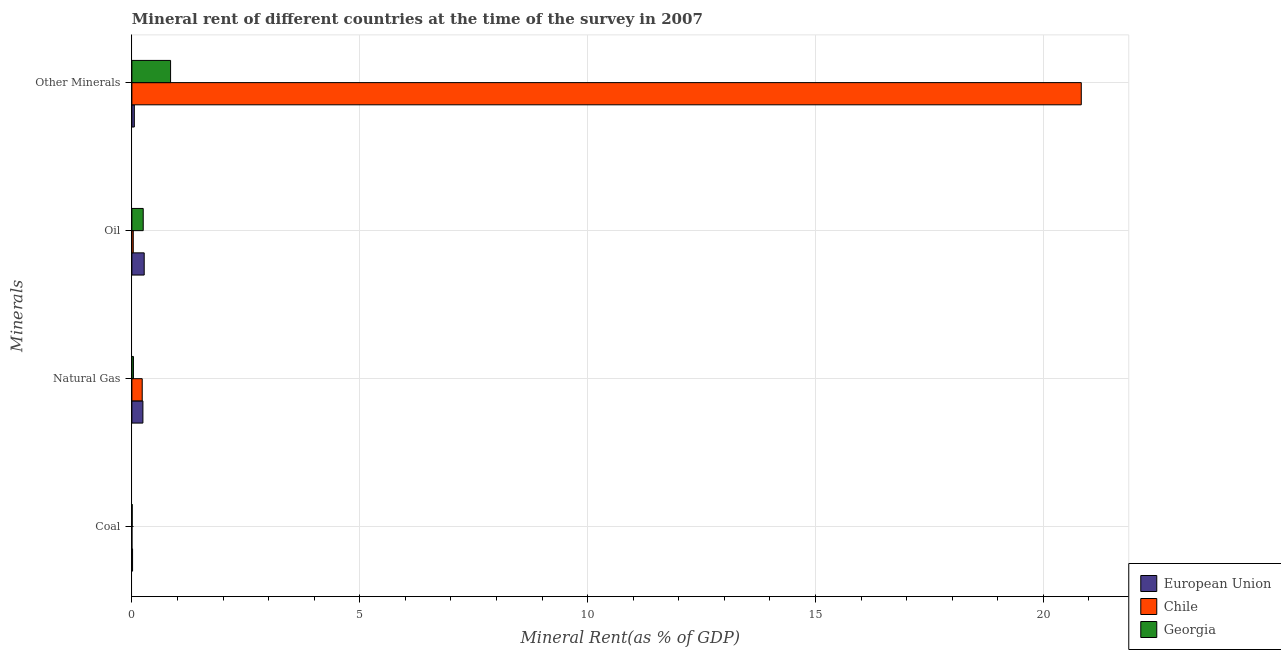How many different coloured bars are there?
Offer a very short reply. 3. Are the number of bars on each tick of the Y-axis equal?
Offer a terse response. Yes. How many bars are there on the 1st tick from the top?
Provide a succinct answer. 3. How many bars are there on the 1st tick from the bottom?
Give a very brief answer. 3. What is the label of the 1st group of bars from the top?
Your answer should be compact. Other Minerals. What is the oil rent in Chile?
Give a very brief answer. 0.03. Across all countries, what is the maximum natural gas rent?
Keep it short and to the point. 0.24. Across all countries, what is the minimum natural gas rent?
Ensure brevity in your answer.  0.03. What is the total oil rent in the graph?
Your answer should be very brief. 0.55. What is the difference between the  rent of other minerals in European Union and that in Chile?
Give a very brief answer. -20.78. What is the difference between the natural gas rent in Chile and the oil rent in European Union?
Your answer should be very brief. -0.04. What is the average  rent of other minerals per country?
Make the answer very short. 7.25. What is the difference between the coal rent and  rent of other minerals in Georgia?
Offer a very short reply. -0.84. In how many countries, is the oil rent greater than 20 %?
Give a very brief answer. 0. What is the ratio of the  rent of other minerals in Chile to that in Georgia?
Your response must be concise. 24.53. Is the  rent of other minerals in Georgia less than that in European Union?
Ensure brevity in your answer.  No. What is the difference between the highest and the second highest coal rent?
Provide a short and direct response. 0.01. What is the difference between the highest and the lowest oil rent?
Your response must be concise. 0.24. Is it the case that in every country, the sum of the natural gas rent and coal rent is greater than the sum of  rent of other minerals and oil rent?
Your answer should be compact. No. What does the 2nd bar from the top in Coal represents?
Offer a very short reply. Chile. What does the 3rd bar from the bottom in Oil represents?
Offer a terse response. Georgia. Is it the case that in every country, the sum of the coal rent and natural gas rent is greater than the oil rent?
Your answer should be compact. No. How many bars are there?
Make the answer very short. 12. Are all the bars in the graph horizontal?
Provide a succinct answer. Yes. How many countries are there in the graph?
Provide a succinct answer. 3. Are the values on the major ticks of X-axis written in scientific E-notation?
Offer a very short reply. No. Does the graph contain any zero values?
Your answer should be compact. No. Does the graph contain grids?
Your answer should be compact. Yes. How are the legend labels stacked?
Your response must be concise. Vertical. What is the title of the graph?
Keep it short and to the point. Mineral rent of different countries at the time of the survey in 2007. What is the label or title of the X-axis?
Provide a succinct answer. Mineral Rent(as % of GDP). What is the label or title of the Y-axis?
Give a very brief answer. Minerals. What is the Mineral Rent(as % of GDP) in European Union in Coal?
Ensure brevity in your answer.  0.01. What is the Mineral Rent(as % of GDP) in Chile in Coal?
Your answer should be compact. 0. What is the Mineral Rent(as % of GDP) in Georgia in Coal?
Give a very brief answer. 0.01. What is the Mineral Rent(as % of GDP) of European Union in Natural Gas?
Your response must be concise. 0.24. What is the Mineral Rent(as % of GDP) of Chile in Natural Gas?
Your response must be concise. 0.23. What is the Mineral Rent(as % of GDP) of Georgia in Natural Gas?
Provide a short and direct response. 0.03. What is the Mineral Rent(as % of GDP) in European Union in Oil?
Ensure brevity in your answer.  0.27. What is the Mineral Rent(as % of GDP) in Chile in Oil?
Ensure brevity in your answer.  0.03. What is the Mineral Rent(as % of GDP) of Georgia in Oil?
Your answer should be compact. 0.25. What is the Mineral Rent(as % of GDP) in European Union in Other Minerals?
Your response must be concise. 0.05. What is the Mineral Rent(as % of GDP) of Chile in Other Minerals?
Offer a terse response. 20.83. What is the Mineral Rent(as % of GDP) of Georgia in Other Minerals?
Offer a very short reply. 0.85. Across all Minerals, what is the maximum Mineral Rent(as % of GDP) in European Union?
Provide a short and direct response. 0.27. Across all Minerals, what is the maximum Mineral Rent(as % of GDP) in Chile?
Give a very brief answer. 20.83. Across all Minerals, what is the maximum Mineral Rent(as % of GDP) of Georgia?
Your response must be concise. 0.85. Across all Minerals, what is the minimum Mineral Rent(as % of GDP) of European Union?
Give a very brief answer. 0.01. Across all Minerals, what is the minimum Mineral Rent(as % of GDP) of Chile?
Your answer should be very brief. 0. Across all Minerals, what is the minimum Mineral Rent(as % of GDP) in Georgia?
Your answer should be very brief. 0.01. What is the total Mineral Rent(as % of GDP) in European Union in the graph?
Offer a very short reply. 0.58. What is the total Mineral Rent(as % of GDP) in Chile in the graph?
Make the answer very short. 21.09. What is the total Mineral Rent(as % of GDP) of Georgia in the graph?
Give a very brief answer. 1.14. What is the difference between the Mineral Rent(as % of GDP) in European Union in Coal and that in Natural Gas?
Your answer should be compact. -0.23. What is the difference between the Mineral Rent(as % of GDP) of Chile in Coal and that in Natural Gas?
Ensure brevity in your answer.  -0.23. What is the difference between the Mineral Rent(as % of GDP) in Georgia in Coal and that in Natural Gas?
Provide a short and direct response. -0.03. What is the difference between the Mineral Rent(as % of GDP) in European Union in Coal and that in Oil?
Offer a very short reply. -0.26. What is the difference between the Mineral Rent(as % of GDP) of Chile in Coal and that in Oil?
Your answer should be very brief. -0.03. What is the difference between the Mineral Rent(as % of GDP) of Georgia in Coal and that in Oil?
Ensure brevity in your answer.  -0.24. What is the difference between the Mineral Rent(as % of GDP) in European Union in Coal and that in Other Minerals?
Keep it short and to the point. -0.04. What is the difference between the Mineral Rent(as % of GDP) of Chile in Coal and that in Other Minerals?
Make the answer very short. -20.83. What is the difference between the Mineral Rent(as % of GDP) in Georgia in Coal and that in Other Minerals?
Keep it short and to the point. -0.84. What is the difference between the Mineral Rent(as % of GDP) in European Union in Natural Gas and that in Oil?
Provide a short and direct response. -0.03. What is the difference between the Mineral Rent(as % of GDP) in Chile in Natural Gas and that in Oil?
Keep it short and to the point. 0.2. What is the difference between the Mineral Rent(as % of GDP) of Georgia in Natural Gas and that in Oil?
Give a very brief answer. -0.21. What is the difference between the Mineral Rent(as % of GDP) in European Union in Natural Gas and that in Other Minerals?
Offer a terse response. 0.19. What is the difference between the Mineral Rent(as % of GDP) of Chile in Natural Gas and that in Other Minerals?
Provide a succinct answer. -20.61. What is the difference between the Mineral Rent(as % of GDP) of Georgia in Natural Gas and that in Other Minerals?
Offer a terse response. -0.81. What is the difference between the Mineral Rent(as % of GDP) of European Union in Oil and that in Other Minerals?
Offer a very short reply. 0.22. What is the difference between the Mineral Rent(as % of GDP) of Chile in Oil and that in Other Minerals?
Keep it short and to the point. -20.8. What is the difference between the Mineral Rent(as % of GDP) of Georgia in Oil and that in Other Minerals?
Make the answer very short. -0.6. What is the difference between the Mineral Rent(as % of GDP) in European Union in Coal and the Mineral Rent(as % of GDP) in Chile in Natural Gas?
Keep it short and to the point. -0.21. What is the difference between the Mineral Rent(as % of GDP) in European Union in Coal and the Mineral Rent(as % of GDP) in Georgia in Natural Gas?
Make the answer very short. -0.02. What is the difference between the Mineral Rent(as % of GDP) in Chile in Coal and the Mineral Rent(as % of GDP) in Georgia in Natural Gas?
Make the answer very short. -0.03. What is the difference between the Mineral Rent(as % of GDP) of European Union in Coal and the Mineral Rent(as % of GDP) of Chile in Oil?
Give a very brief answer. -0.02. What is the difference between the Mineral Rent(as % of GDP) in European Union in Coal and the Mineral Rent(as % of GDP) in Georgia in Oil?
Your answer should be very brief. -0.23. What is the difference between the Mineral Rent(as % of GDP) of Chile in Coal and the Mineral Rent(as % of GDP) of Georgia in Oil?
Provide a short and direct response. -0.25. What is the difference between the Mineral Rent(as % of GDP) in European Union in Coal and the Mineral Rent(as % of GDP) in Chile in Other Minerals?
Provide a short and direct response. -20.82. What is the difference between the Mineral Rent(as % of GDP) of European Union in Coal and the Mineral Rent(as % of GDP) of Georgia in Other Minerals?
Make the answer very short. -0.83. What is the difference between the Mineral Rent(as % of GDP) of Chile in Coal and the Mineral Rent(as % of GDP) of Georgia in Other Minerals?
Make the answer very short. -0.85. What is the difference between the Mineral Rent(as % of GDP) of European Union in Natural Gas and the Mineral Rent(as % of GDP) of Chile in Oil?
Keep it short and to the point. 0.21. What is the difference between the Mineral Rent(as % of GDP) in European Union in Natural Gas and the Mineral Rent(as % of GDP) in Georgia in Oil?
Make the answer very short. -0.01. What is the difference between the Mineral Rent(as % of GDP) in Chile in Natural Gas and the Mineral Rent(as % of GDP) in Georgia in Oil?
Offer a very short reply. -0.02. What is the difference between the Mineral Rent(as % of GDP) in European Union in Natural Gas and the Mineral Rent(as % of GDP) in Chile in Other Minerals?
Give a very brief answer. -20.59. What is the difference between the Mineral Rent(as % of GDP) of European Union in Natural Gas and the Mineral Rent(as % of GDP) of Georgia in Other Minerals?
Ensure brevity in your answer.  -0.61. What is the difference between the Mineral Rent(as % of GDP) in Chile in Natural Gas and the Mineral Rent(as % of GDP) in Georgia in Other Minerals?
Provide a short and direct response. -0.62. What is the difference between the Mineral Rent(as % of GDP) of European Union in Oil and the Mineral Rent(as % of GDP) of Chile in Other Minerals?
Your answer should be very brief. -20.56. What is the difference between the Mineral Rent(as % of GDP) in European Union in Oil and the Mineral Rent(as % of GDP) in Georgia in Other Minerals?
Your answer should be very brief. -0.58. What is the difference between the Mineral Rent(as % of GDP) of Chile in Oil and the Mineral Rent(as % of GDP) of Georgia in Other Minerals?
Ensure brevity in your answer.  -0.82. What is the average Mineral Rent(as % of GDP) in European Union per Minerals?
Your answer should be very brief. 0.15. What is the average Mineral Rent(as % of GDP) in Chile per Minerals?
Provide a short and direct response. 5.27. What is the average Mineral Rent(as % of GDP) in Georgia per Minerals?
Offer a terse response. 0.28. What is the difference between the Mineral Rent(as % of GDP) in European Union and Mineral Rent(as % of GDP) in Chile in Coal?
Provide a succinct answer. 0.01. What is the difference between the Mineral Rent(as % of GDP) of European Union and Mineral Rent(as % of GDP) of Georgia in Coal?
Make the answer very short. 0.01. What is the difference between the Mineral Rent(as % of GDP) of Chile and Mineral Rent(as % of GDP) of Georgia in Coal?
Ensure brevity in your answer.  -0.01. What is the difference between the Mineral Rent(as % of GDP) in European Union and Mineral Rent(as % of GDP) in Chile in Natural Gas?
Give a very brief answer. 0.02. What is the difference between the Mineral Rent(as % of GDP) in European Union and Mineral Rent(as % of GDP) in Georgia in Natural Gas?
Provide a succinct answer. 0.21. What is the difference between the Mineral Rent(as % of GDP) of Chile and Mineral Rent(as % of GDP) of Georgia in Natural Gas?
Your answer should be very brief. 0.19. What is the difference between the Mineral Rent(as % of GDP) of European Union and Mineral Rent(as % of GDP) of Chile in Oil?
Make the answer very short. 0.24. What is the difference between the Mineral Rent(as % of GDP) in European Union and Mineral Rent(as % of GDP) in Georgia in Oil?
Provide a succinct answer. 0.02. What is the difference between the Mineral Rent(as % of GDP) of Chile and Mineral Rent(as % of GDP) of Georgia in Oil?
Offer a very short reply. -0.22. What is the difference between the Mineral Rent(as % of GDP) of European Union and Mineral Rent(as % of GDP) of Chile in Other Minerals?
Your response must be concise. -20.78. What is the difference between the Mineral Rent(as % of GDP) of European Union and Mineral Rent(as % of GDP) of Georgia in Other Minerals?
Your answer should be compact. -0.8. What is the difference between the Mineral Rent(as % of GDP) of Chile and Mineral Rent(as % of GDP) of Georgia in Other Minerals?
Your answer should be compact. 19.98. What is the ratio of the Mineral Rent(as % of GDP) in European Union in Coal to that in Natural Gas?
Make the answer very short. 0.06. What is the ratio of the Mineral Rent(as % of GDP) in Chile in Coal to that in Natural Gas?
Your response must be concise. 0.01. What is the ratio of the Mineral Rent(as % of GDP) in Georgia in Coal to that in Natural Gas?
Your answer should be compact. 0.21. What is the ratio of the Mineral Rent(as % of GDP) in European Union in Coal to that in Oil?
Ensure brevity in your answer.  0.06. What is the ratio of the Mineral Rent(as % of GDP) of Chile in Coal to that in Oil?
Make the answer very short. 0.05. What is the ratio of the Mineral Rent(as % of GDP) of Georgia in Coal to that in Oil?
Offer a terse response. 0.03. What is the ratio of the Mineral Rent(as % of GDP) in European Union in Coal to that in Other Minerals?
Ensure brevity in your answer.  0.28. What is the ratio of the Mineral Rent(as % of GDP) of Chile in Coal to that in Other Minerals?
Provide a short and direct response. 0. What is the ratio of the Mineral Rent(as % of GDP) of Georgia in Coal to that in Other Minerals?
Offer a very short reply. 0.01. What is the ratio of the Mineral Rent(as % of GDP) of European Union in Natural Gas to that in Oil?
Your answer should be very brief. 0.9. What is the ratio of the Mineral Rent(as % of GDP) in Chile in Natural Gas to that in Oil?
Give a very brief answer. 7.44. What is the ratio of the Mineral Rent(as % of GDP) in Georgia in Natural Gas to that in Oil?
Provide a succinct answer. 0.14. What is the ratio of the Mineral Rent(as % of GDP) in European Union in Natural Gas to that in Other Minerals?
Offer a terse response. 4.49. What is the ratio of the Mineral Rent(as % of GDP) of Chile in Natural Gas to that in Other Minerals?
Provide a short and direct response. 0.01. What is the ratio of the Mineral Rent(as % of GDP) of Georgia in Natural Gas to that in Other Minerals?
Provide a short and direct response. 0.04. What is the ratio of the Mineral Rent(as % of GDP) in European Union in Oil to that in Other Minerals?
Ensure brevity in your answer.  5.01. What is the ratio of the Mineral Rent(as % of GDP) of Chile in Oil to that in Other Minerals?
Provide a short and direct response. 0. What is the ratio of the Mineral Rent(as % of GDP) in Georgia in Oil to that in Other Minerals?
Provide a succinct answer. 0.29. What is the difference between the highest and the second highest Mineral Rent(as % of GDP) of European Union?
Your answer should be very brief. 0.03. What is the difference between the highest and the second highest Mineral Rent(as % of GDP) of Chile?
Provide a succinct answer. 20.61. What is the difference between the highest and the second highest Mineral Rent(as % of GDP) in Georgia?
Provide a succinct answer. 0.6. What is the difference between the highest and the lowest Mineral Rent(as % of GDP) in European Union?
Offer a very short reply. 0.26. What is the difference between the highest and the lowest Mineral Rent(as % of GDP) in Chile?
Keep it short and to the point. 20.83. What is the difference between the highest and the lowest Mineral Rent(as % of GDP) of Georgia?
Your answer should be very brief. 0.84. 